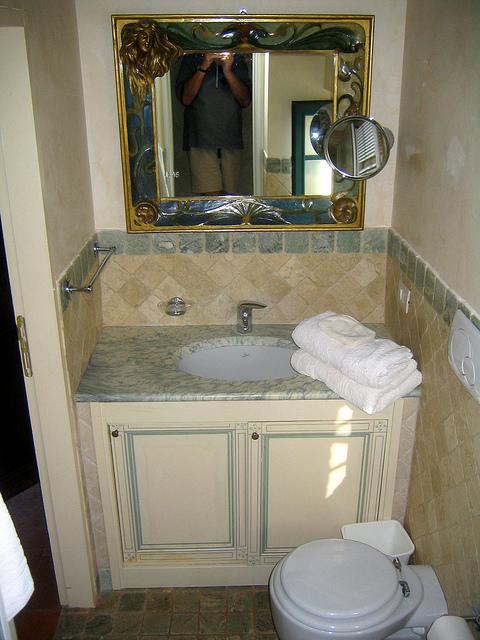How many towels are there?
Give a very brief answer. 2. What is the room in the photo?
Give a very brief answer. Bathroom. How many different types of tiles were used in this bathroom?
Write a very short answer. 2. Is the sink basin clear?
Be succinct. Yes. 